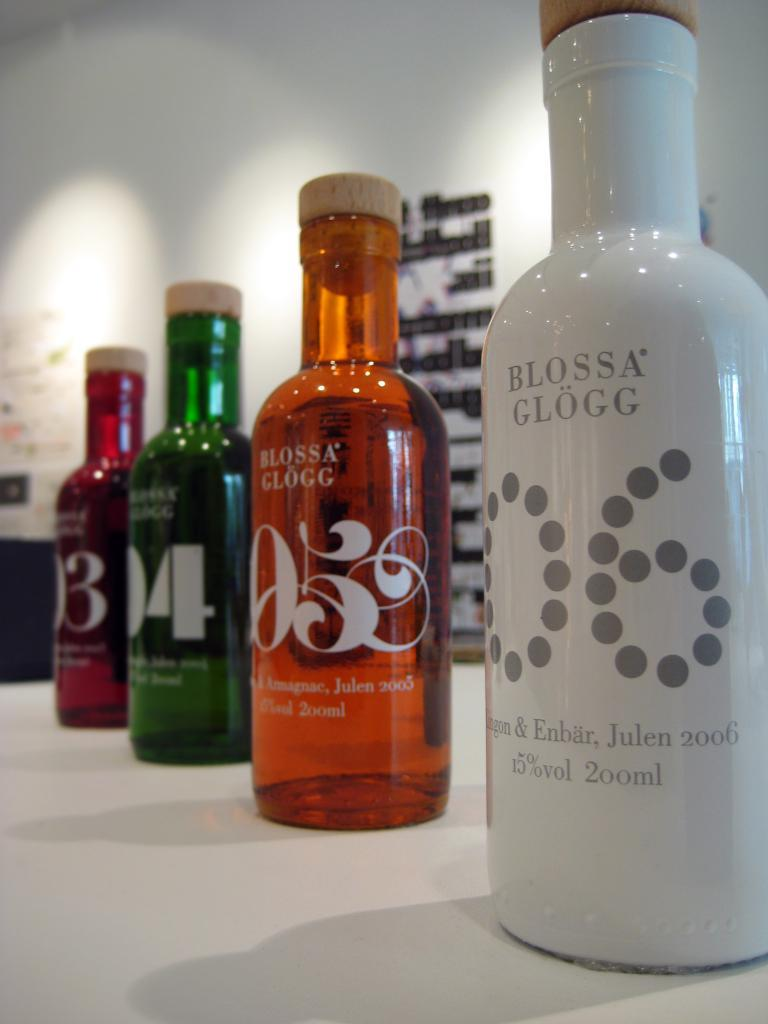<image>
Present a compact description of the photo's key features. Different color of bottles of Blossa Glogg sitting on a counter 